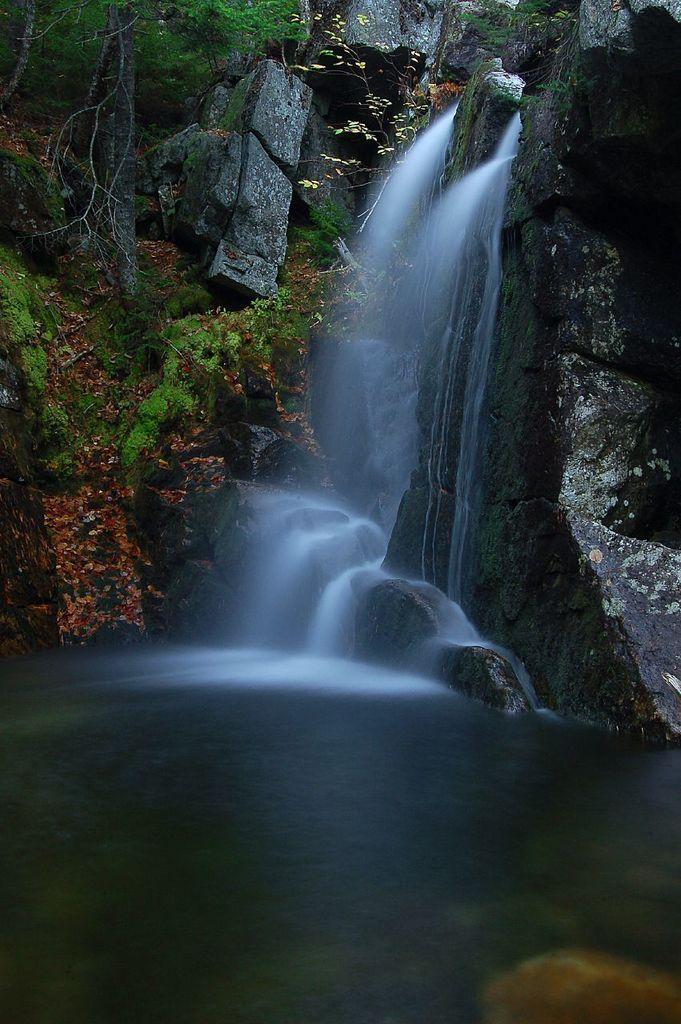How would you summarize this image in a sentence or two? In this image I can see few trees,waterfall and black color rock mountain. 